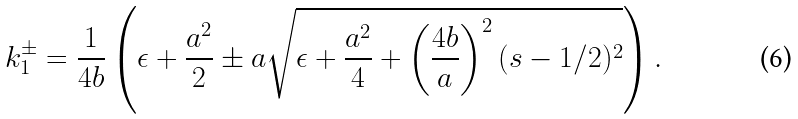<formula> <loc_0><loc_0><loc_500><loc_500>k ^ { \pm } _ { 1 } = \frac { 1 } { 4 b } \left ( \epsilon + \frac { a ^ { 2 } } { 2 } \pm a \sqrt { \epsilon + \frac { a ^ { 2 } } { 4 } + \left ( \frac { 4 b } { a } \right ) ^ { 2 } ( s - 1 / 2 ) ^ { 2 } } \right ) .</formula> 